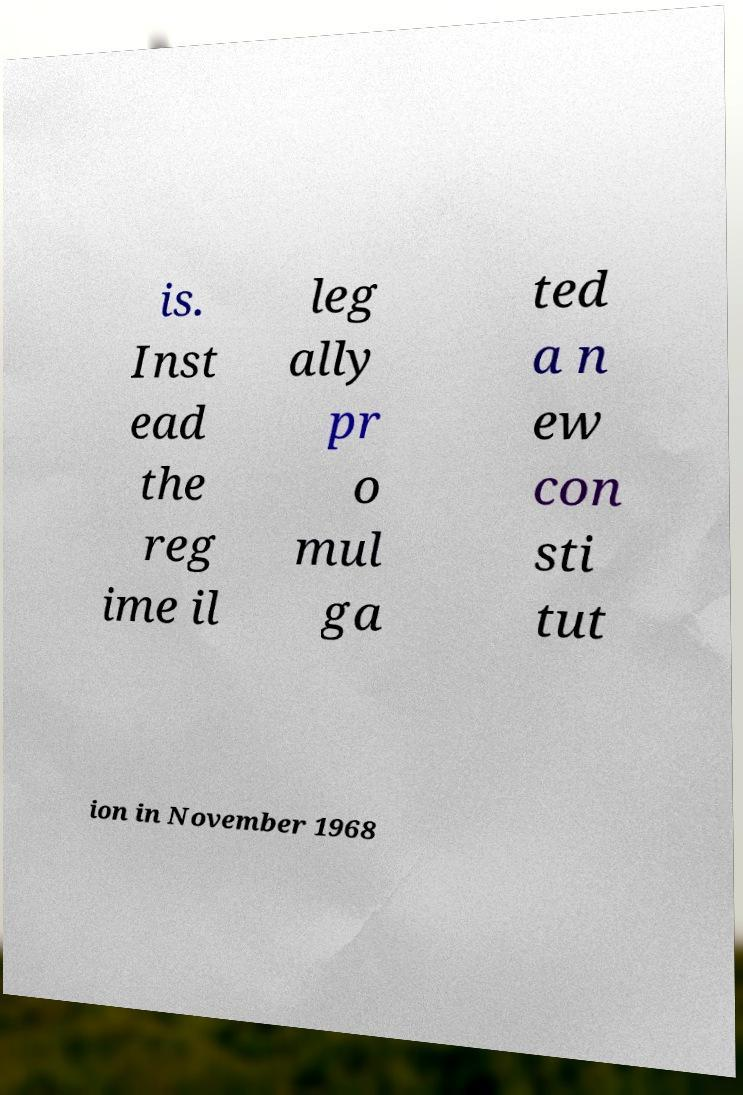What messages or text are displayed in this image? I need them in a readable, typed format. is. Inst ead the reg ime il leg ally pr o mul ga ted a n ew con sti tut ion in November 1968 